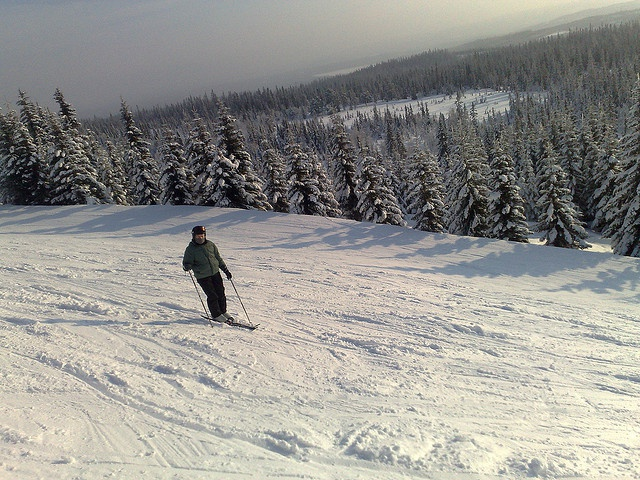Describe the objects in this image and their specific colors. I can see people in gray, black, and darkgray tones and skis in gray, black, darkgray, and lightgray tones in this image. 